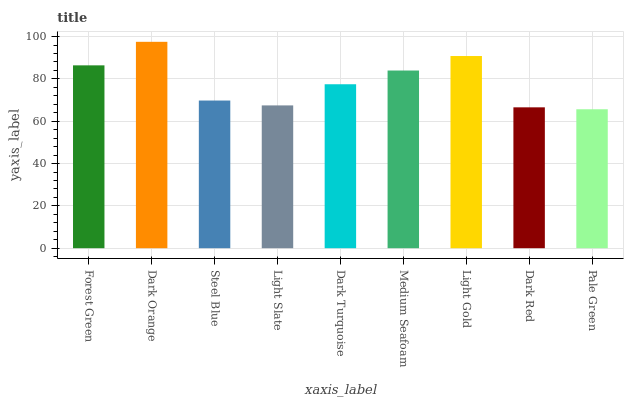Is Pale Green the minimum?
Answer yes or no. Yes. Is Dark Orange the maximum?
Answer yes or no. Yes. Is Steel Blue the minimum?
Answer yes or no. No. Is Steel Blue the maximum?
Answer yes or no. No. Is Dark Orange greater than Steel Blue?
Answer yes or no. Yes. Is Steel Blue less than Dark Orange?
Answer yes or no. Yes. Is Steel Blue greater than Dark Orange?
Answer yes or no. No. Is Dark Orange less than Steel Blue?
Answer yes or no. No. Is Dark Turquoise the high median?
Answer yes or no. Yes. Is Dark Turquoise the low median?
Answer yes or no. Yes. Is Dark Red the high median?
Answer yes or no. No. Is Dark Orange the low median?
Answer yes or no. No. 